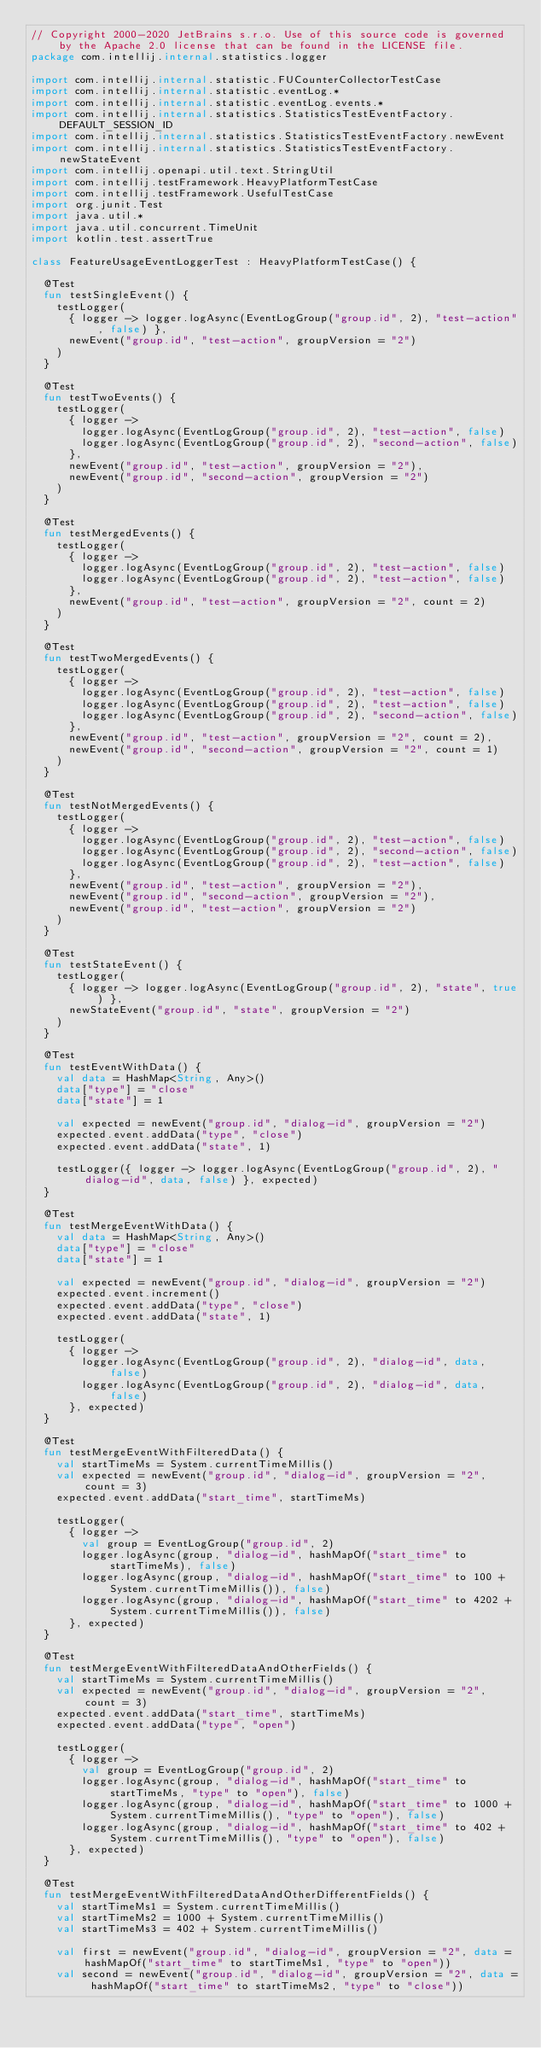Convert code to text. <code><loc_0><loc_0><loc_500><loc_500><_Kotlin_>// Copyright 2000-2020 JetBrains s.r.o. Use of this source code is governed by the Apache 2.0 license that can be found in the LICENSE file.
package com.intellij.internal.statistics.logger

import com.intellij.internal.statistic.FUCounterCollectorTestCase
import com.intellij.internal.statistic.eventLog.*
import com.intellij.internal.statistic.eventLog.events.*
import com.intellij.internal.statistics.StatisticsTestEventFactory.DEFAULT_SESSION_ID
import com.intellij.internal.statistics.StatisticsTestEventFactory.newEvent
import com.intellij.internal.statistics.StatisticsTestEventFactory.newStateEvent
import com.intellij.openapi.util.text.StringUtil
import com.intellij.testFramework.HeavyPlatformTestCase
import com.intellij.testFramework.UsefulTestCase
import org.junit.Test
import java.util.*
import java.util.concurrent.TimeUnit
import kotlin.test.assertTrue

class FeatureUsageEventLoggerTest : HeavyPlatformTestCase() {

  @Test
  fun testSingleEvent() {
    testLogger(
      { logger -> logger.logAsync(EventLogGroup("group.id", 2), "test-action", false) },
      newEvent("group.id", "test-action", groupVersion = "2")
    )
  }

  @Test
  fun testTwoEvents() {
    testLogger(
      { logger ->
        logger.logAsync(EventLogGroup("group.id", 2), "test-action", false)
        logger.logAsync(EventLogGroup("group.id", 2), "second-action", false)
      },
      newEvent("group.id", "test-action", groupVersion = "2"),
      newEvent("group.id", "second-action", groupVersion = "2")
    )
  }

  @Test
  fun testMergedEvents() {
    testLogger(
      { logger ->
        logger.logAsync(EventLogGroup("group.id", 2), "test-action", false)
        logger.logAsync(EventLogGroup("group.id", 2), "test-action", false)
      },
      newEvent("group.id", "test-action", groupVersion = "2", count = 2)
    )
  }

  @Test
  fun testTwoMergedEvents() {
    testLogger(
      { logger ->
        logger.logAsync(EventLogGroup("group.id", 2), "test-action", false)
        logger.logAsync(EventLogGroup("group.id", 2), "test-action", false)
        logger.logAsync(EventLogGroup("group.id", 2), "second-action", false)
      },
      newEvent("group.id", "test-action", groupVersion = "2", count = 2),
      newEvent("group.id", "second-action", groupVersion = "2", count = 1)
    )
  }

  @Test
  fun testNotMergedEvents() {
    testLogger(
      { logger ->
        logger.logAsync(EventLogGroup("group.id", 2), "test-action", false)
        logger.logAsync(EventLogGroup("group.id", 2), "second-action", false)
        logger.logAsync(EventLogGroup("group.id", 2), "test-action", false)
      },
      newEvent("group.id", "test-action", groupVersion = "2"),
      newEvent("group.id", "second-action", groupVersion = "2"),
      newEvent("group.id", "test-action", groupVersion = "2")
    )
  }

  @Test
  fun testStateEvent() {
    testLogger(
      { logger -> logger.logAsync(EventLogGroup("group.id", 2), "state", true) },
      newStateEvent("group.id", "state", groupVersion = "2")
    )
  }

  @Test
  fun testEventWithData() {
    val data = HashMap<String, Any>()
    data["type"] = "close"
    data["state"] = 1

    val expected = newEvent("group.id", "dialog-id", groupVersion = "2")
    expected.event.addData("type", "close")
    expected.event.addData("state", 1)

    testLogger({ logger -> logger.logAsync(EventLogGroup("group.id", 2), "dialog-id", data, false) }, expected)
  }

  @Test
  fun testMergeEventWithData() {
    val data = HashMap<String, Any>()
    data["type"] = "close"
    data["state"] = 1

    val expected = newEvent("group.id", "dialog-id", groupVersion = "2")
    expected.event.increment()
    expected.event.addData("type", "close")
    expected.event.addData("state", 1)

    testLogger(
      { logger ->
        logger.logAsync(EventLogGroup("group.id", 2), "dialog-id", data, false)
        logger.logAsync(EventLogGroup("group.id", 2), "dialog-id", data, false)
      }, expected)
  }

  @Test
  fun testMergeEventWithFilteredData() {
    val startTimeMs = System.currentTimeMillis()
    val expected = newEvent("group.id", "dialog-id", groupVersion = "2", count = 3)
    expected.event.addData("start_time", startTimeMs)

    testLogger(
      { logger ->
        val group = EventLogGroup("group.id", 2)
        logger.logAsync(group, "dialog-id", hashMapOf("start_time" to startTimeMs), false)
        logger.logAsync(group, "dialog-id", hashMapOf("start_time" to 100 + System.currentTimeMillis()), false)
        logger.logAsync(group, "dialog-id", hashMapOf("start_time" to 4202 + System.currentTimeMillis()), false)
      }, expected)
  }

  @Test
  fun testMergeEventWithFilteredDataAndOtherFields() {
    val startTimeMs = System.currentTimeMillis()
    val expected = newEvent("group.id", "dialog-id", groupVersion = "2", count = 3)
    expected.event.addData("start_time", startTimeMs)
    expected.event.addData("type", "open")

    testLogger(
      { logger ->
        val group = EventLogGroup("group.id", 2)
        logger.logAsync(group, "dialog-id", hashMapOf("start_time" to startTimeMs, "type" to "open"), false)
        logger.logAsync(group, "dialog-id", hashMapOf("start_time" to 1000 + System.currentTimeMillis(), "type" to "open"), false)
        logger.logAsync(group, "dialog-id", hashMapOf("start_time" to 402 + System.currentTimeMillis(), "type" to "open"), false)
      }, expected)
  }

  @Test
  fun testMergeEventWithFilteredDataAndOtherDifferentFields() {
    val startTimeMs1 = System.currentTimeMillis()
    val startTimeMs2 = 1000 + System.currentTimeMillis()
    val startTimeMs3 = 402 + System.currentTimeMillis()

    val first = newEvent("group.id", "dialog-id", groupVersion = "2", data = hashMapOf("start_time" to startTimeMs1, "type" to "open"))
    val second = newEvent("group.id", "dialog-id", groupVersion = "2", data = hashMapOf("start_time" to startTimeMs2, "type" to "close"))</code> 